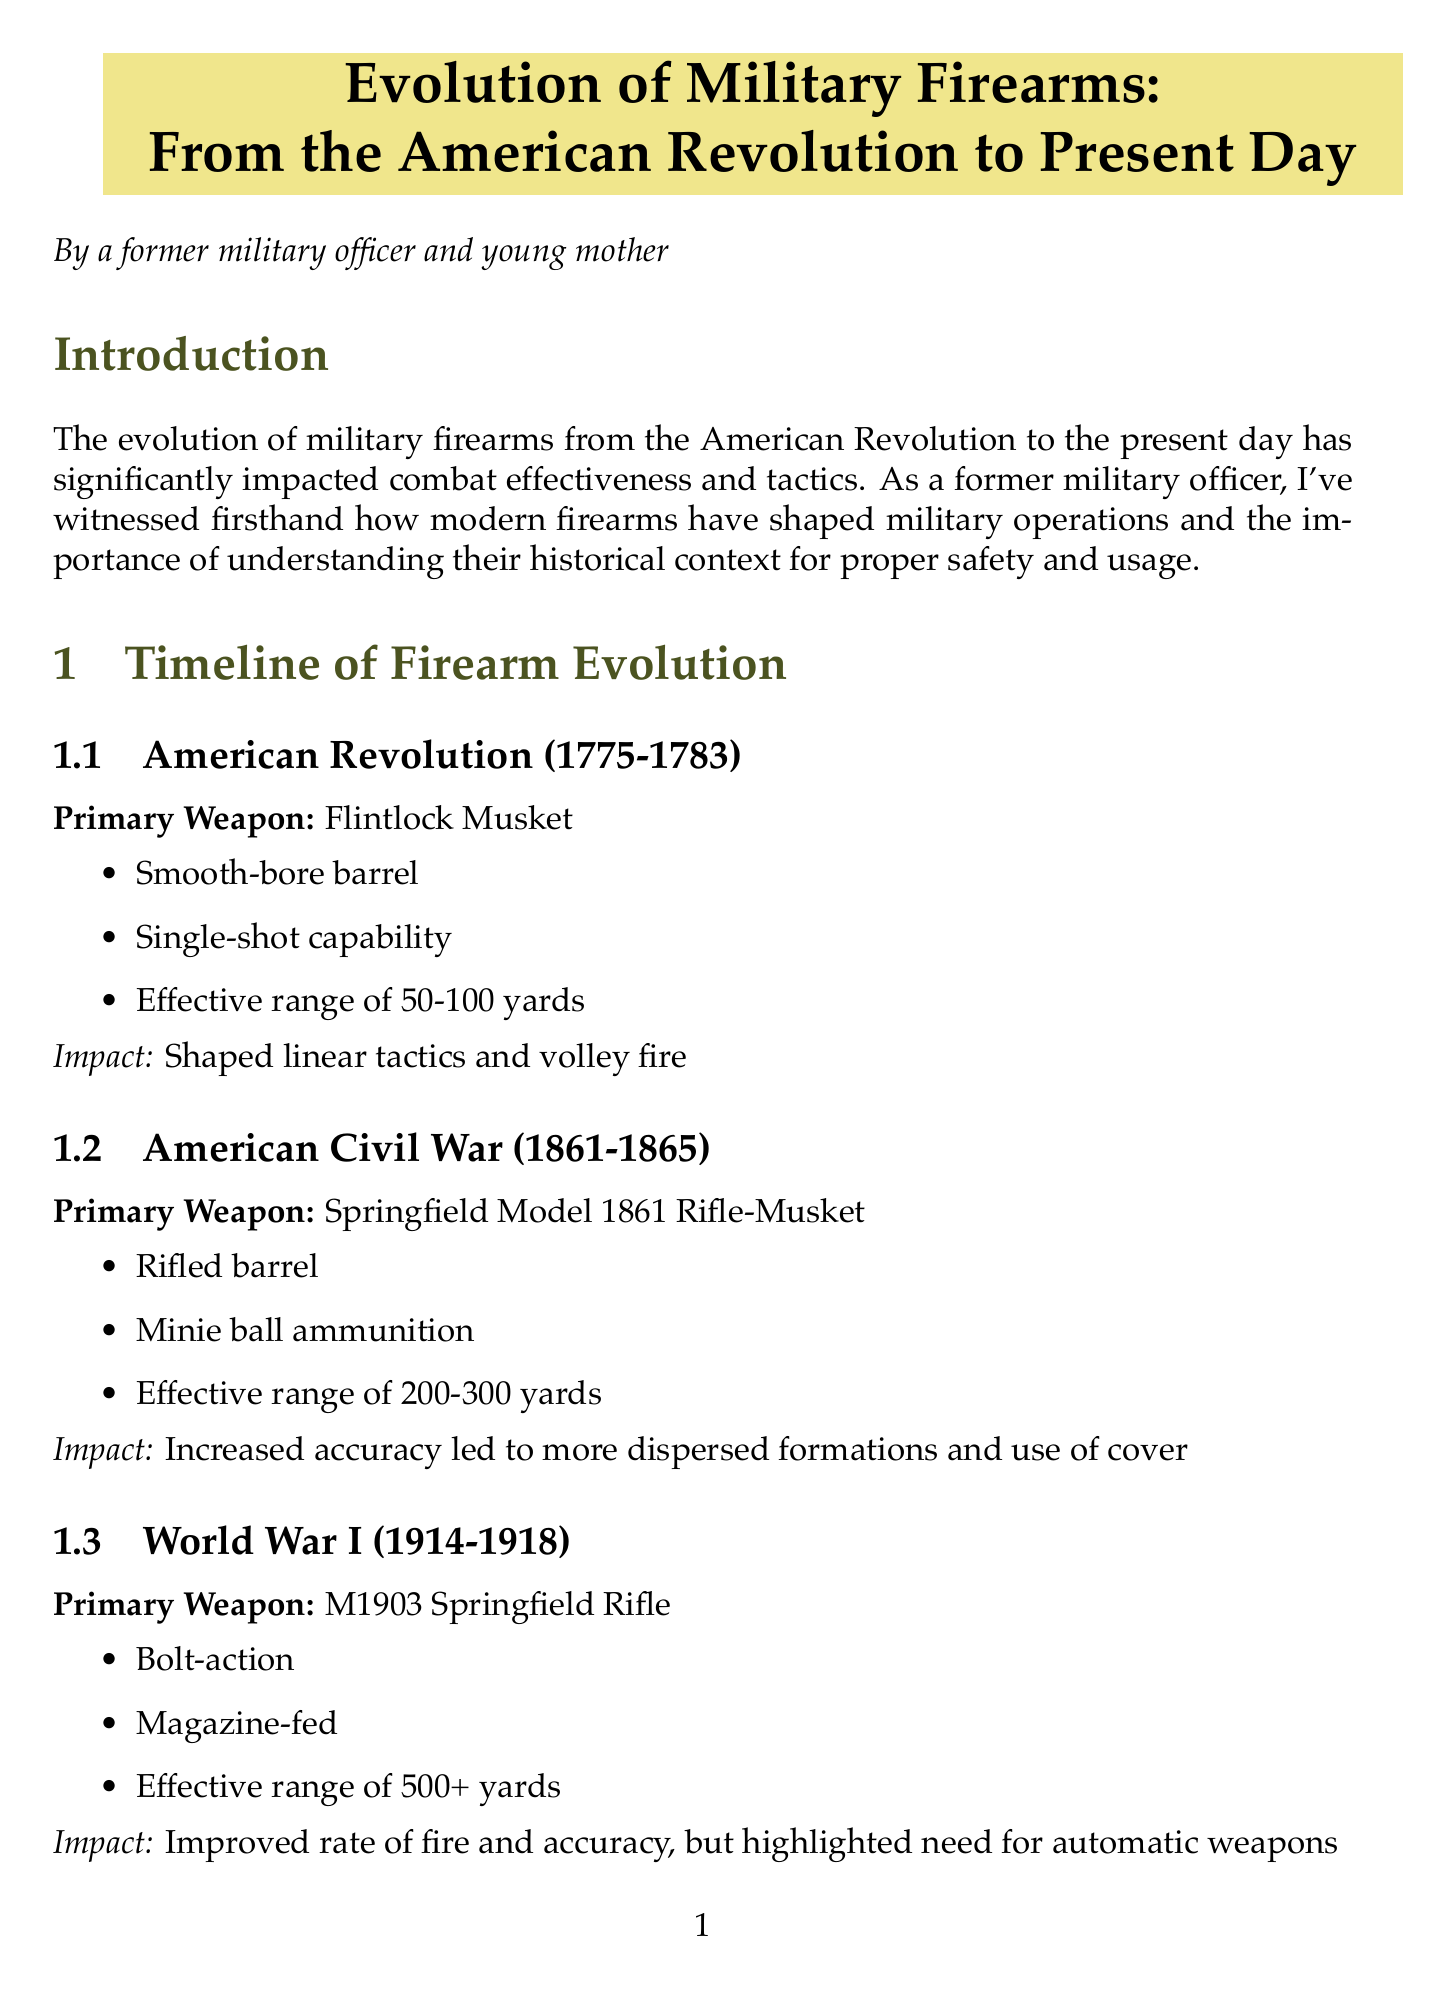what was the primary weapon during the American Revolution? The primary weapon used during the American Revolution is identified in the document as the Flintlock Musket.
Answer: Flintlock Musket what is the effective range of the M1 Garand? The effective range of the M1 Garand is specified as being over 400 yards in the document.
Answer: 400+ yards how did rifling impact accuracy and range? The document states that rifling dramatically improved accuracy and range.
Answer: Dramatically improved accuracy and range which technological advancement primarily reduced battlefield smoke? The advancement that reduced battlefield smoke is smokeless powder, as mentioned in the document.
Answer: Smokeless powder what was a key feature of the M16 Rifle? The document notes that a key feature of the M16 Rifle is its fully automatic capability.
Answer: Fully automatic capability how did the Springfield Model 1861 Rifle-Musket influence formations? The document describes that increased accuracy from the Springfield Model 1861 led to more dispersed formations and use of cover.
Answer: Dispersed formations and use of cover what safety consideration is associated with automatic actions? The safety consideration related to automatic actions emphasized the heightened importance of trigger discipline and muzzle awareness.
Answer: Trigger discipline and muzzle awareness what is the effective range of the M1903 Springfield Rifle? The effective range for the M1903 Springfield Rifle is noted to be over 500 yards in the document.
Answer: 500+ yards what is a modern practice for firearm safety education? The document states that modern practices include an emphasis on proper training and muscle memory for firearm safety.
Answer: Proper training and muscle memory 